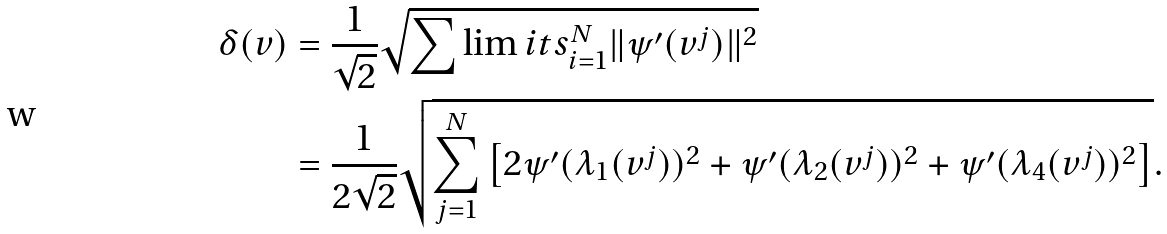<formula> <loc_0><loc_0><loc_500><loc_500>\delta ( v ) & = \frac { 1 } { \sqrt { 2 } } \sqrt { \sum \lim i t s _ { i = 1 } ^ { N } \| \psi ^ { \prime } ( v ^ { j } ) \| ^ { 2 } } \\ & = \frac { 1 } { 2 \sqrt { 2 } } \sqrt { \sum _ { j = 1 } ^ { N } \left [ 2 \psi ^ { \prime } ( \lambda _ { 1 } ( v ^ { j } ) ) ^ { 2 } + \psi ^ { \prime } ( \lambda _ { 2 } ( v ^ { j } ) ) ^ { 2 } + \psi ^ { \prime } ( \lambda _ { 4 } ( v ^ { j } ) ) ^ { 2 } \right ] } .</formula> 